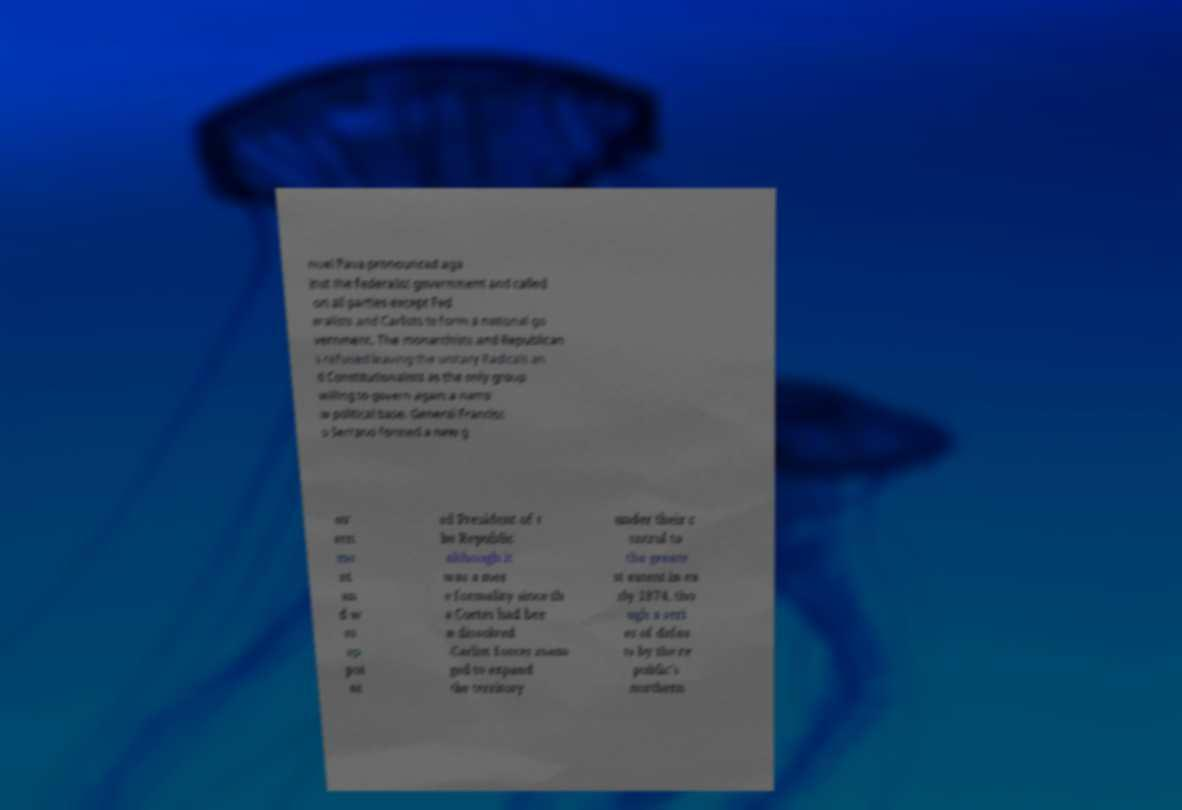Can you accurately transcribe the text from the provided image for me? nuel Pava pronounced aga inst the federalist government and called on all parties except Fed eralists and Carlists to form a national go vernment. The monarchists and Republican s refused leaving the unitary Radicals an d Constitutionalists as the only group willing to govern again a narro w political base. General Francisc o Serrano formed a new g ov ern me nt an d w as ap poi nt ed President of t he Republic although it was a mer e formality since th e Cortes had bee n dissolved .Carlist forces mana ged to expand the territory under their c ontrol to the greate st extent in ea rly 1874, tho ugh a seri es of defea ts by the re public's northern 